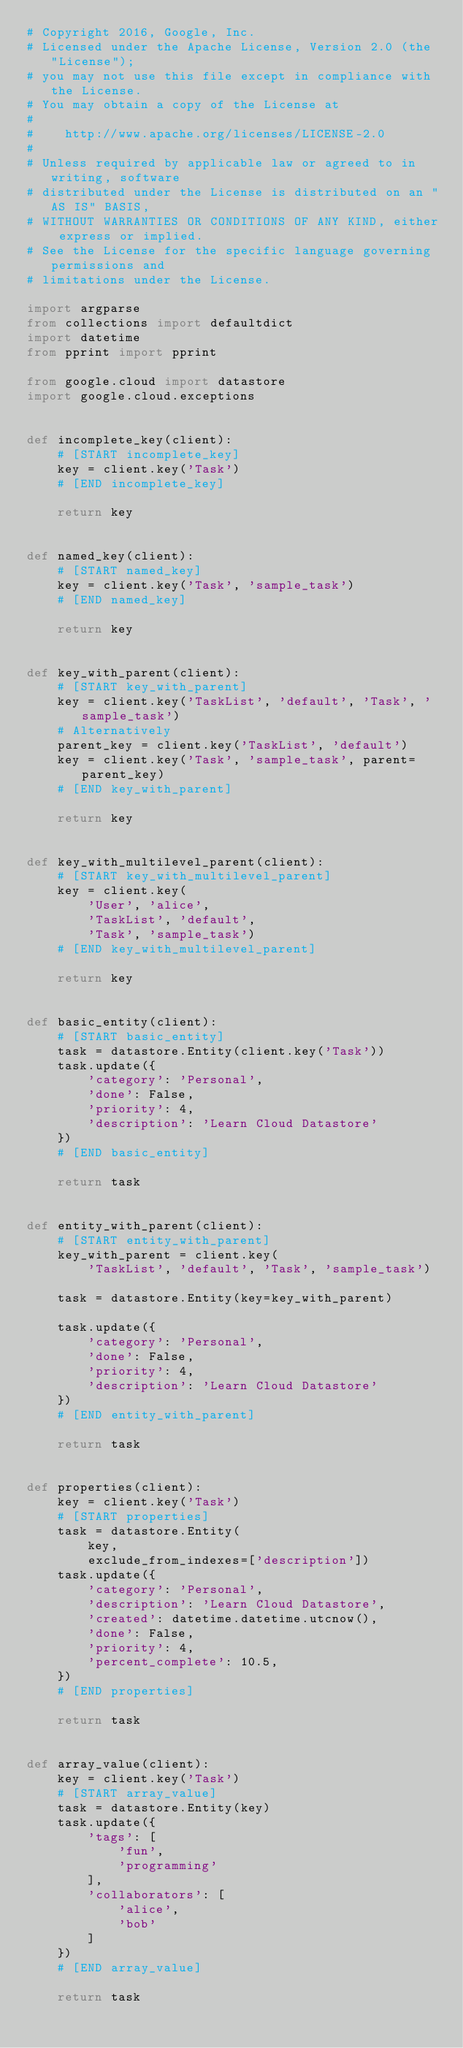<code> <loc_0><loc_0><loc_500><loc_500><_Python_># Copyright 2016, Google, Inc.
# Licensed under the Apache License, Version 2.0 (the "License");
# you may not use this file except in compliance with the License.
# You may obtain a copy of the License at
#
#    http://www.apache.org/licenses/LICENSE-2.0
#
# Unless required by applicable law or agreed to in writing, software
# distributed under the License is distributed on an "AS IS" BASIS,
# WITHOUT WARRANTIES OR CONDITIONS OF ANY KIND, either express or implied.
# See the License for the specific language governing permissions and
# limitations under the License.

import argparse
from collections import defaultdict
import datetime
from pprint import pprint

from google.cloud import datastore
import google.cloud.exceptions


def incomplete_key(client):
    # [START incomplete_key]
    key = client.key('Task')
    # [END incomplete_key]

    return key


def named_key(client):
    # [START named_key]
    key = client.key('Task', 'sample_task')
    # [END named_key]

    return key


def key_with_parent(client):
    # [START key_with_parent]
    key = client.key('TaskList', 'default', 'Task', 'sample_task')
    # Alternatively
    parent_key = client.key('TaskList', 'default')
    key = client.key('Task', 'sample_task', parent=parent_key)
    # [END key_with_parent]

    return key


def key_with_multilevel_parent(client):
    # [START key_with_multilevel_parent]
    key = client.key(
        'User', 'alice',
        'TaskList', 'default',
        'Task', 'sample_task')
    # [END key_with_multilevel_parent]

    return key


def basic_entity(client):
    # [START basic_entity]
    task = datastore.Entity(client.key('Task'))
    task.update({
        'category': 'Personal',
        'done': False,
        'priority': 4,
        'description': 'Learn Cloud Datastore'
    })
    # [END basic_entity]

    return task


def entity_with_parent(client):
    # [START entity_with_parent]
    key_with_parent = client.key(
        'TaskList', 'default', 'Task', 'sample_task')

    task = datastore.Entity(key=key_with_parent)

    task.update({
        'category': 'Personal',
        'done': False,
        'priority': 4,
        'description': 'Learn Cloud Datastore'
    })
    # [END entity_with_parent]

    return task


def properties(client):
    key = client.key('Task')
    # [START properties]
    task = datastore.Entity(
        key,
        exclude_from_indexes=['description'])
    task.update({
        'category': 'Personal',
        'description': 'Learn Cloud Datastore',
        'created': datetime.datetime.utcnow(),
        'done': False,
        'priority': 4,
        'percent_complete': 10.5,
    })
    # [END properties]

    return task


def array_value(client):
    key = client.key('Task')
    # [START array_value]
    task = datastore.Entity(key)
    task.update({
        'tags': [
            'fun',
            'programming'
        ],
        'collaborators': [
            'alice',
            'bob'
        ]
    })
    # [END array_value]

    return task

</code> 